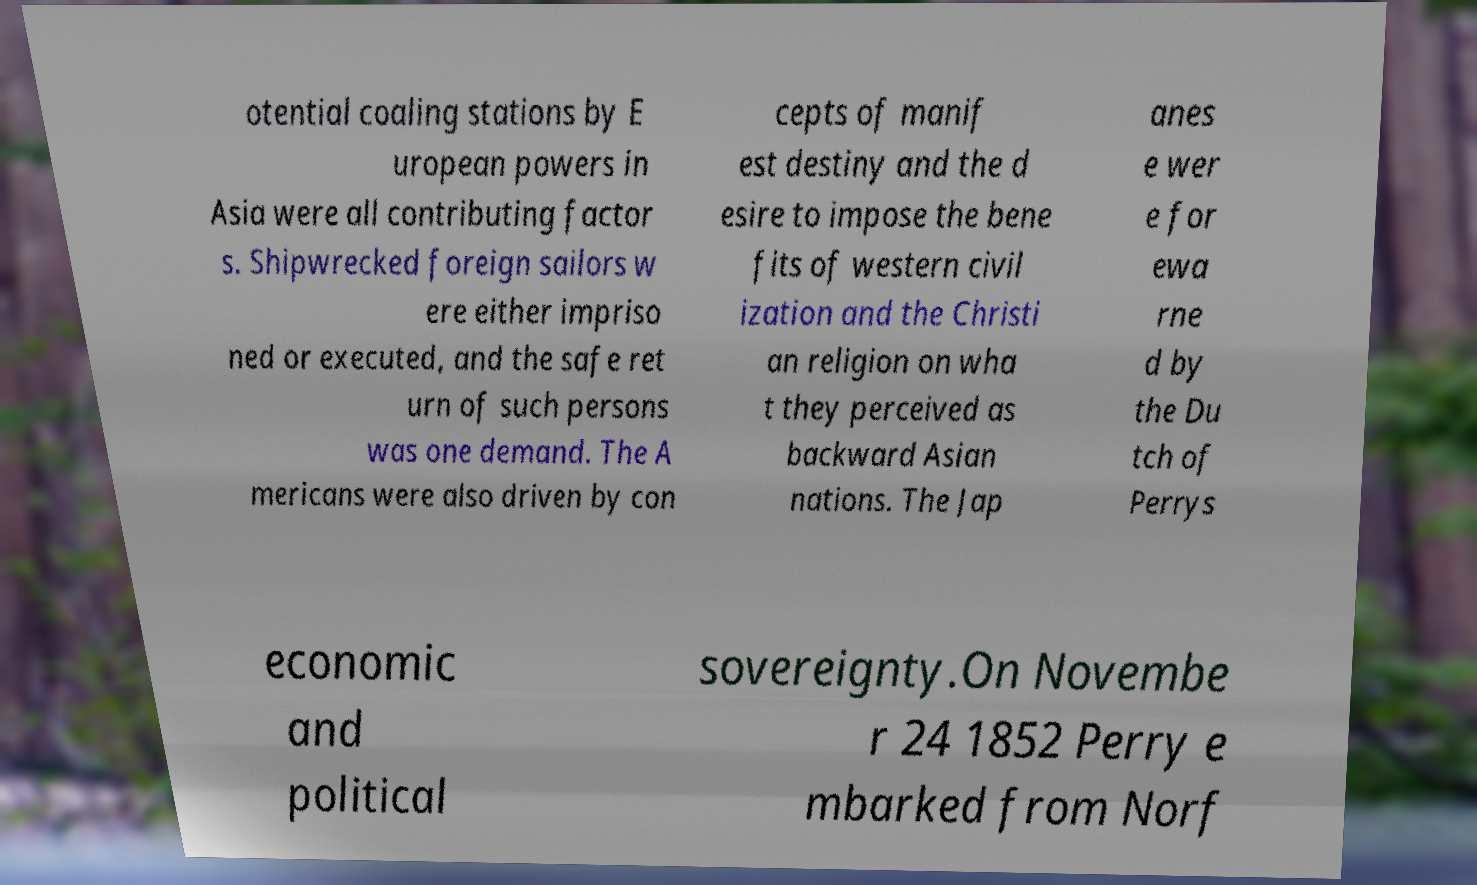What messages or text are displayed in this image? I need them in a readable, typed format. otential coaling stations by E uropean powers in Asia were all contributing factor s. Shipwrecked foreign sailors w ere either impriso ned or executed, and the safe ret urn of such persons was one demand. The A mericans were also driven by con cepts of manif est destiny and the d esire to impose the bene fits of western civil ization and the Christi an religion on wha t they perceived as backward Asian nations. The Jap anes e wer e for ewa rne d by the Du tch of Perrys economic and political sovereignty.On Novembe r 24 1852 Perry e mbarked from Norf 